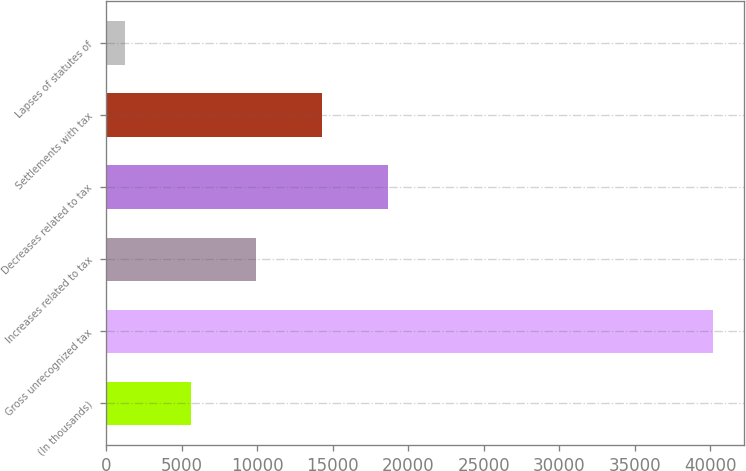<chart> <loc_0><loc_0><loc_500><loc_500><bar_chart><fcel>(In thousands)<fcel>Gross unrecognized tax<fcel>Increases related to tax<fcel>Decreases related to tax<fcel>Settlements with tax<fcel>Lapses of statutes of<nl><fcel>5594.9<fcel>40191<fcel>9955.8<fcel>18677.6<fcel>14316.7<fcel>1234<nl></chart> 